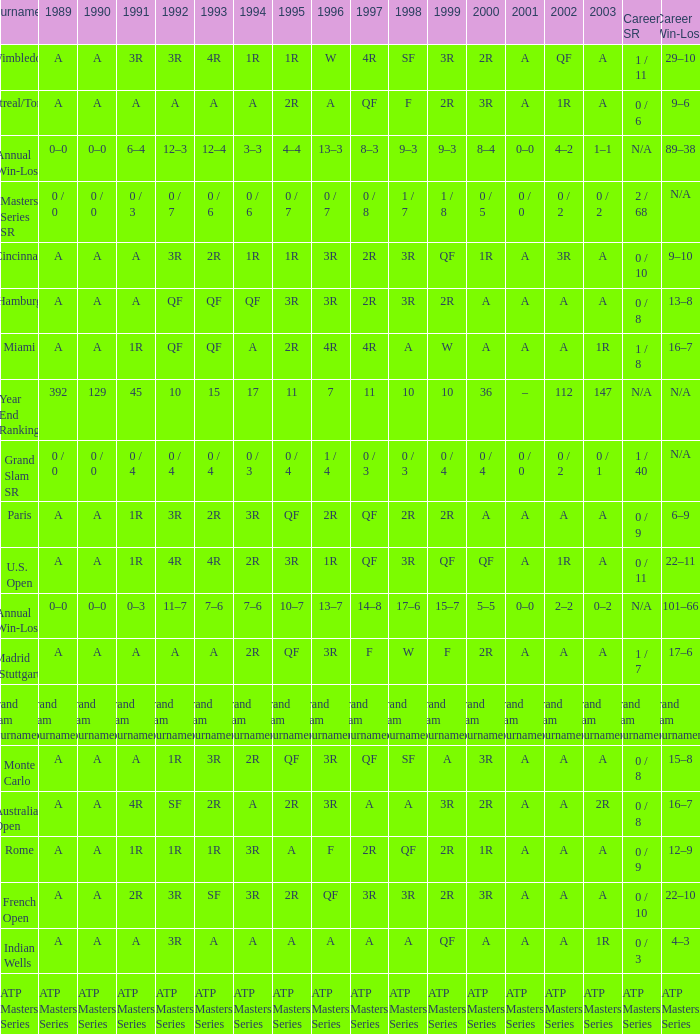What was the 1997 value when 2002 was A and 2003 was 1R? A, 4R. 